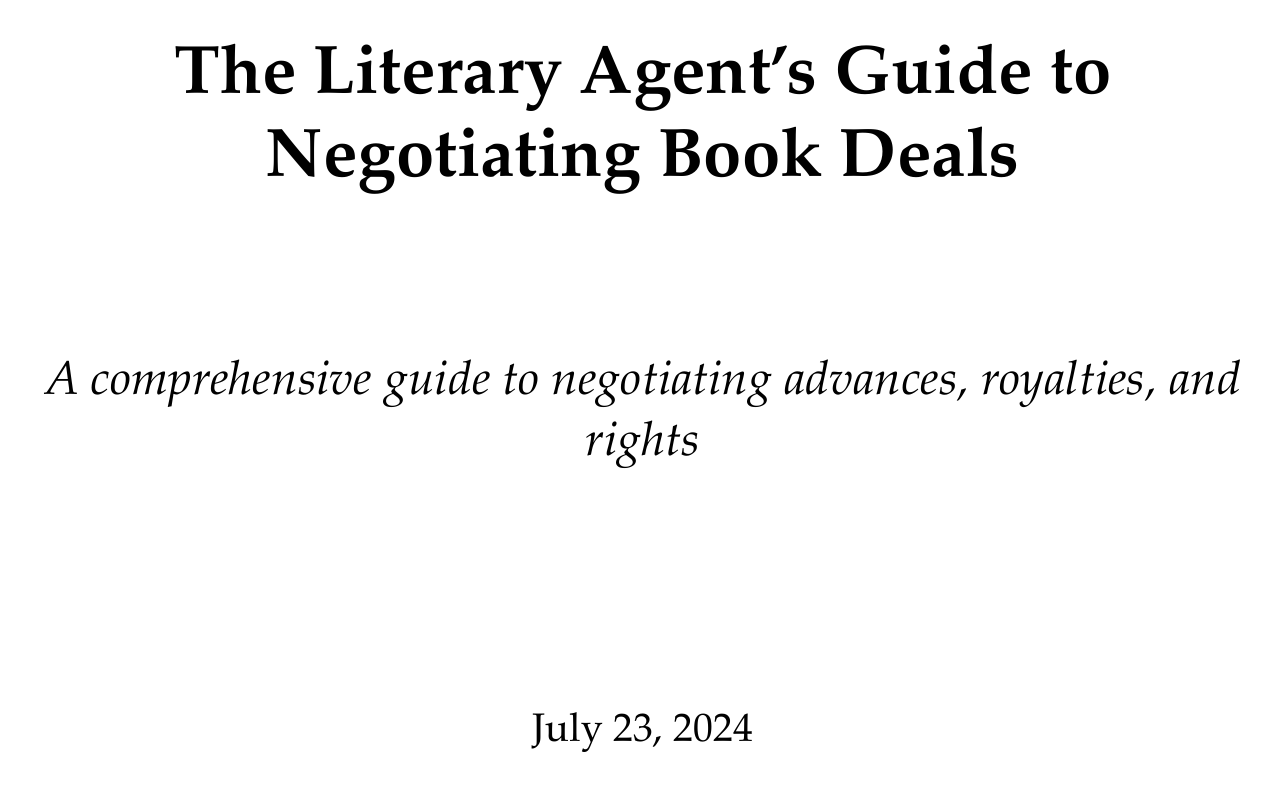What is the manual title? The title is explicitly stated at the beginning of the document.
Answer: The Literary Agent's Guide to Negotiating Book Deals What is the range of typical royalty rates for hardcovers? The document specifies a range for standard royalty rates for hardcovers.
Answer: 7.5% to 15% What should be researched to determine a fair advance? The document outlines key considerations for determining a fair advance in negotiating book deals.
Answer: Recent deals, author's platform, publisher's financial capabilities What is an advance? The document defines an advance and its implications in book deals.
Answer: An upfront payment made to an author against future royalties What should be negotiated in multi-book deals? The document provides guidance on negotiating terms for multi-book deals.
Answer: Separate advances for each book What are subsidiary rights? The document mentions subsidiary rights as part of rights and licensing discussions.
Answer: Translation, film/TV, merchandising, and more What type of clauses are important in contract terms? Various clauses are discussed in the section on contract terms.
Answer: Option clauses, out-of-print clauses, delivery and acceptance What does the agency model for ebooks affect? The document describes the effects of the agency model in the context of ebook sales.
Answer: How royalties are calculated and paid What is a key takeaway from the conclusion? The conclusion summarizes the manual's main points on negotiation strategies.
Answer: Tailor your negotiation strategy to each client and project 